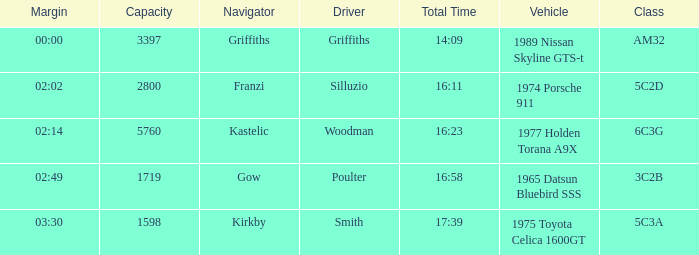What is the lowest capacity for the 1975 toyota celica 1600gt? 1598.0. 